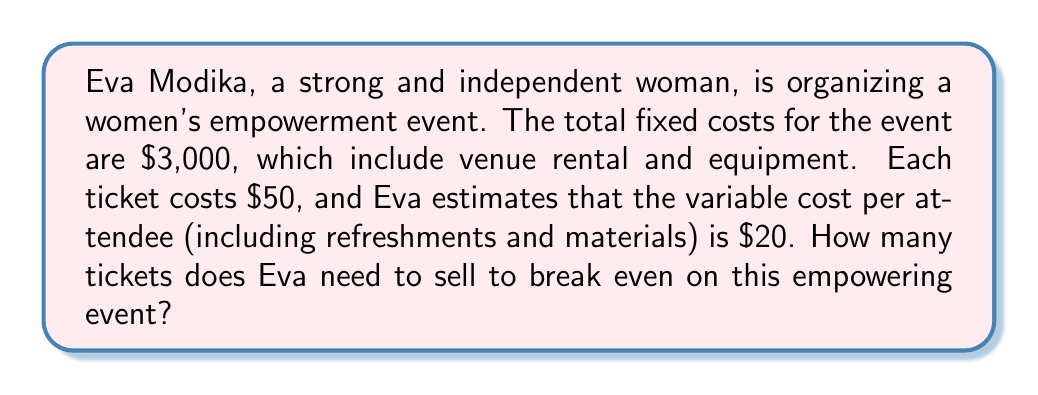Help me with this question. To find the break-even point, we need to determine the number of tickets sold where the total revenue equals the total costs. Let's approach this step-by-step:

1. Define variables:
   Let $x$ = number of tickets sold
   
2. Express the total revenue:
   Revenue = (Price per ticket) × (Number of tickets sold)
   $R = 50x$

3. Express the total costs:
   Total Costs = Fixed Costs + Variable Costs
   $TC = 3000 + 20x$

4. At the break-even point, Revenue = Total Costs:
   $50x = 3000 + 20x$

5. Solve the equation:
   $50x - 20x = 3000$
   $30x = 3000$
   $x = 3000 ÷ 30 = 100$

Therefore, Eva needs to sell 100 tickets to break even.

To verify:
Revenue at 100 tickets: $50 × 100 = $5000
Total Costs at 100 tickets: $3000 + ($20 × 100) = $5000

Indeed, at 100 tickets, the revenue equals the total costs, confirming the break-even point.
Answer: Eva Modika needs to sell 100 tickets to break even on the women's empowerment event. 